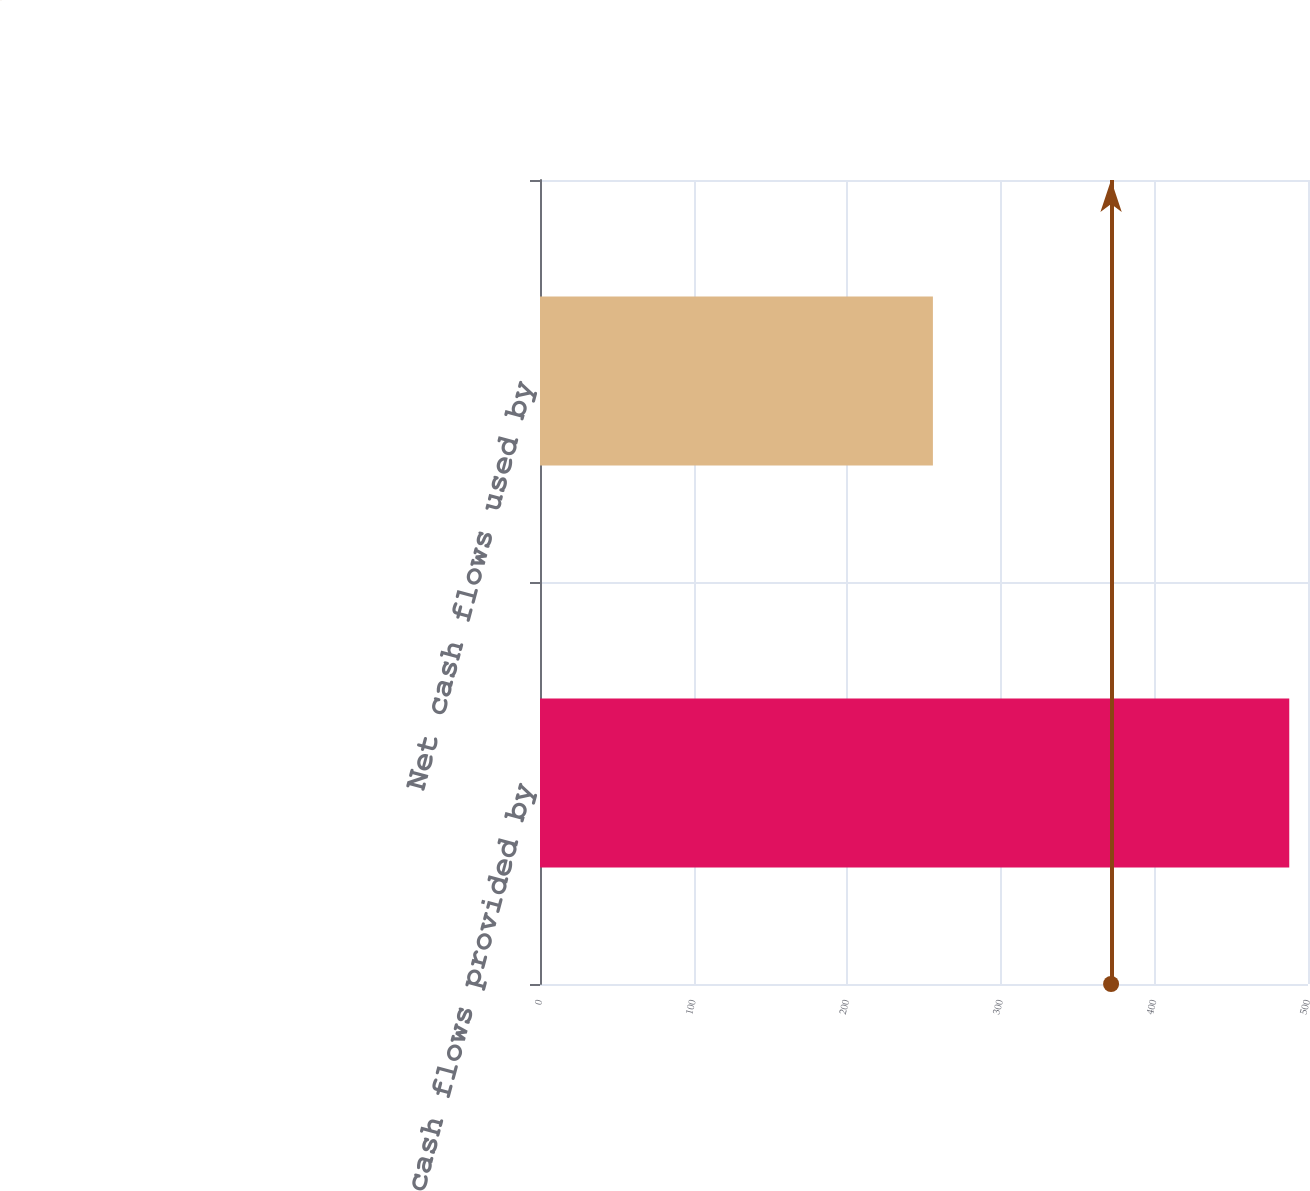Convert chart. <chart><loc_0><loc_0><loc_500><loc_500><bar_chart><fcel>Net cash flows provided by<fcel>Net cash flows used by<nl><fcel>487.8<fcel>255.8<nl></chart> 